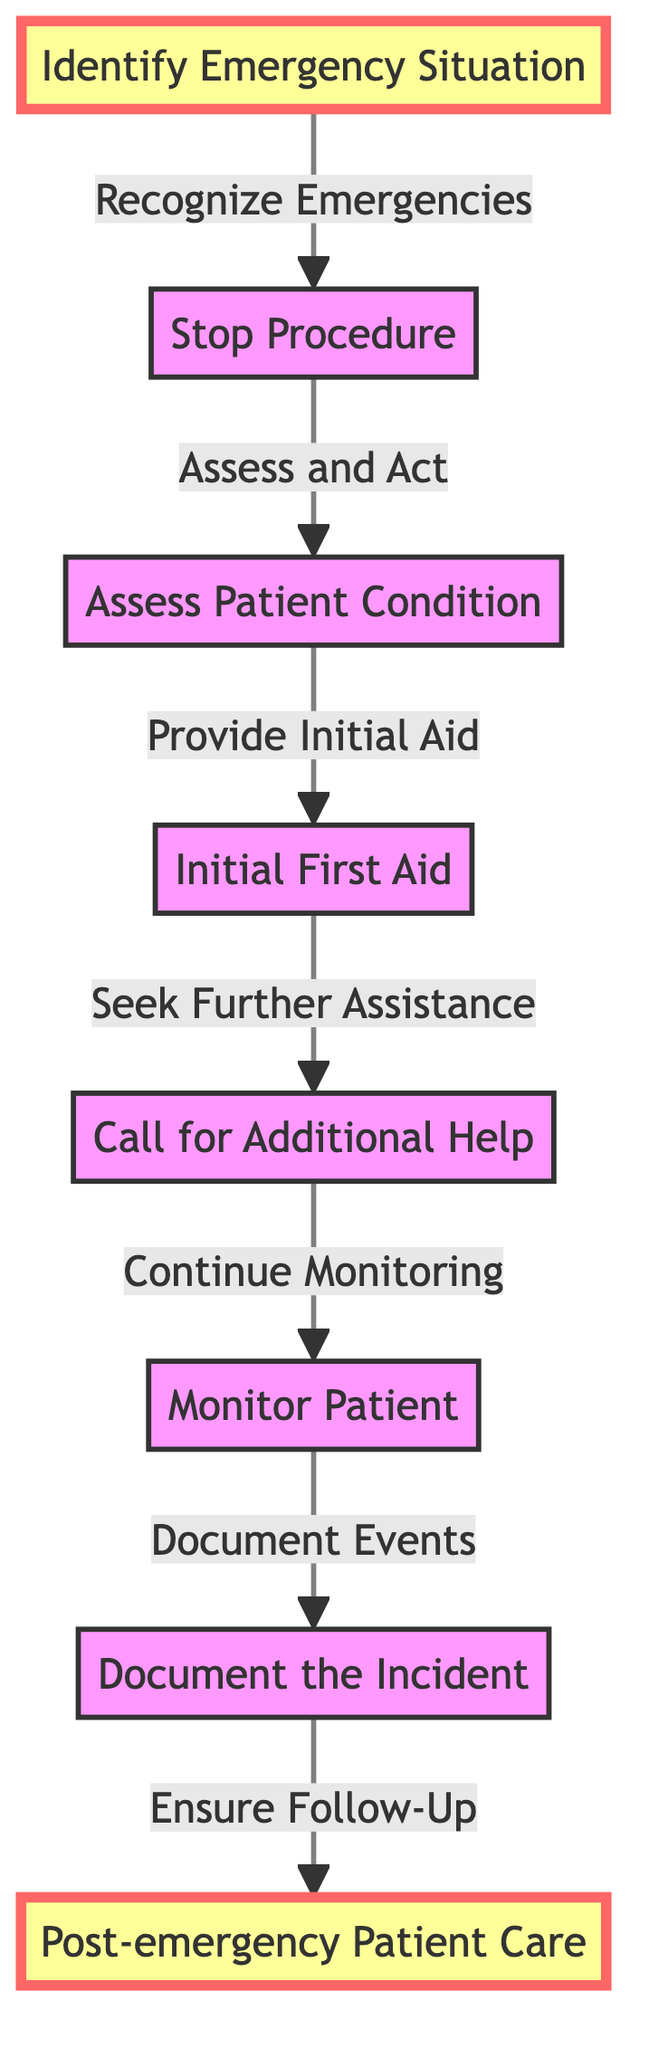What is the first step in an emergency protocol? The first step in the diagram is "Identify Emergency Situation," which involves recognizing signs of distress or unusual patient reactions.
Answer: Identify Emergency Situation How many nodes are there in the diagram? By counting the individual nodes listed, there are a total of 8 distinct actions or concepts in the diagram.
Answer: 8 What follows after "Stop Procedure"? The immediate next step after "Stop Procedure" is "Assess Patient Condition," which indicates that once the procedure is halted, the patient's condition is assessed.
Answer: Assess Patient Condition Which node comes just before "Post-emergency Patient Care"? The node that precedes "Post-emergency Patient Care" is "Document the Incident." This suggests that documenting the emergency details occurs before the follow-up care is provided.
Answer: Document the Incident What action is taken after "Initial First Aid"? After "Initial First Aid," the action taken is "Call for Additional Help," meaning that once first aid is administered, further assistance is sought if necessary.
Answer: Call for Additional Help What do you do once “Monitor Patient” is completed? Once "Monitor Patient" is completed, the next step is to "Document the Incident," indicating that monitoring is followed by recording what occurred during the emergency.
Answer: Document the Incident How does “Call for Additional Help” relate to “Monitor Patient”? "Call for Additional Help" leads into the action of "Monitor Patient," meaning that contacting additional personnel or services happens while still keeping an eye on the patient's condition.
Answer: Continue Monitoring How many edges connect the nodes in the diagram? By counting the edges that link the nodes, there are a total of 7 connections shown in the diagram that represent the flow from one action to the next.
Answer: 7 